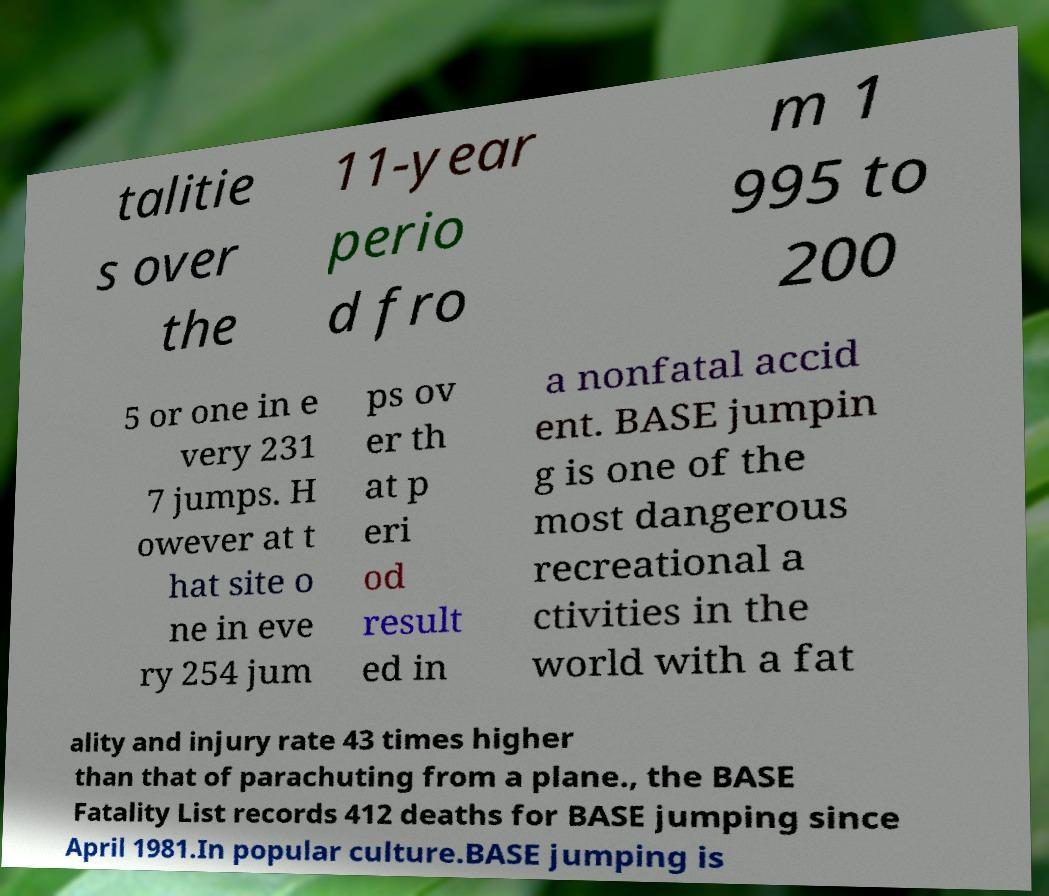Can you read and provide the text displayed in the image?This photo seems to have some interesting text. Can you extract and type it out for me? talitie s over the 11-year perio d fro m 1 995 to 200 5 or one in e very 231 7 jumps. H owever at t hat site o ne in eve ry 254 jum ps ov er th at p eri od result ed in a nonfatal accid ent. BASE jumpin g is one of the most dangerous recreational a ctivities in the world with a fat ality and injury rate 43 times higher than that of parachuting from a plane., the BASE Fatality List records 412 deaths for BASE jumping since April 1981.In popular culture.BASE jumping is 